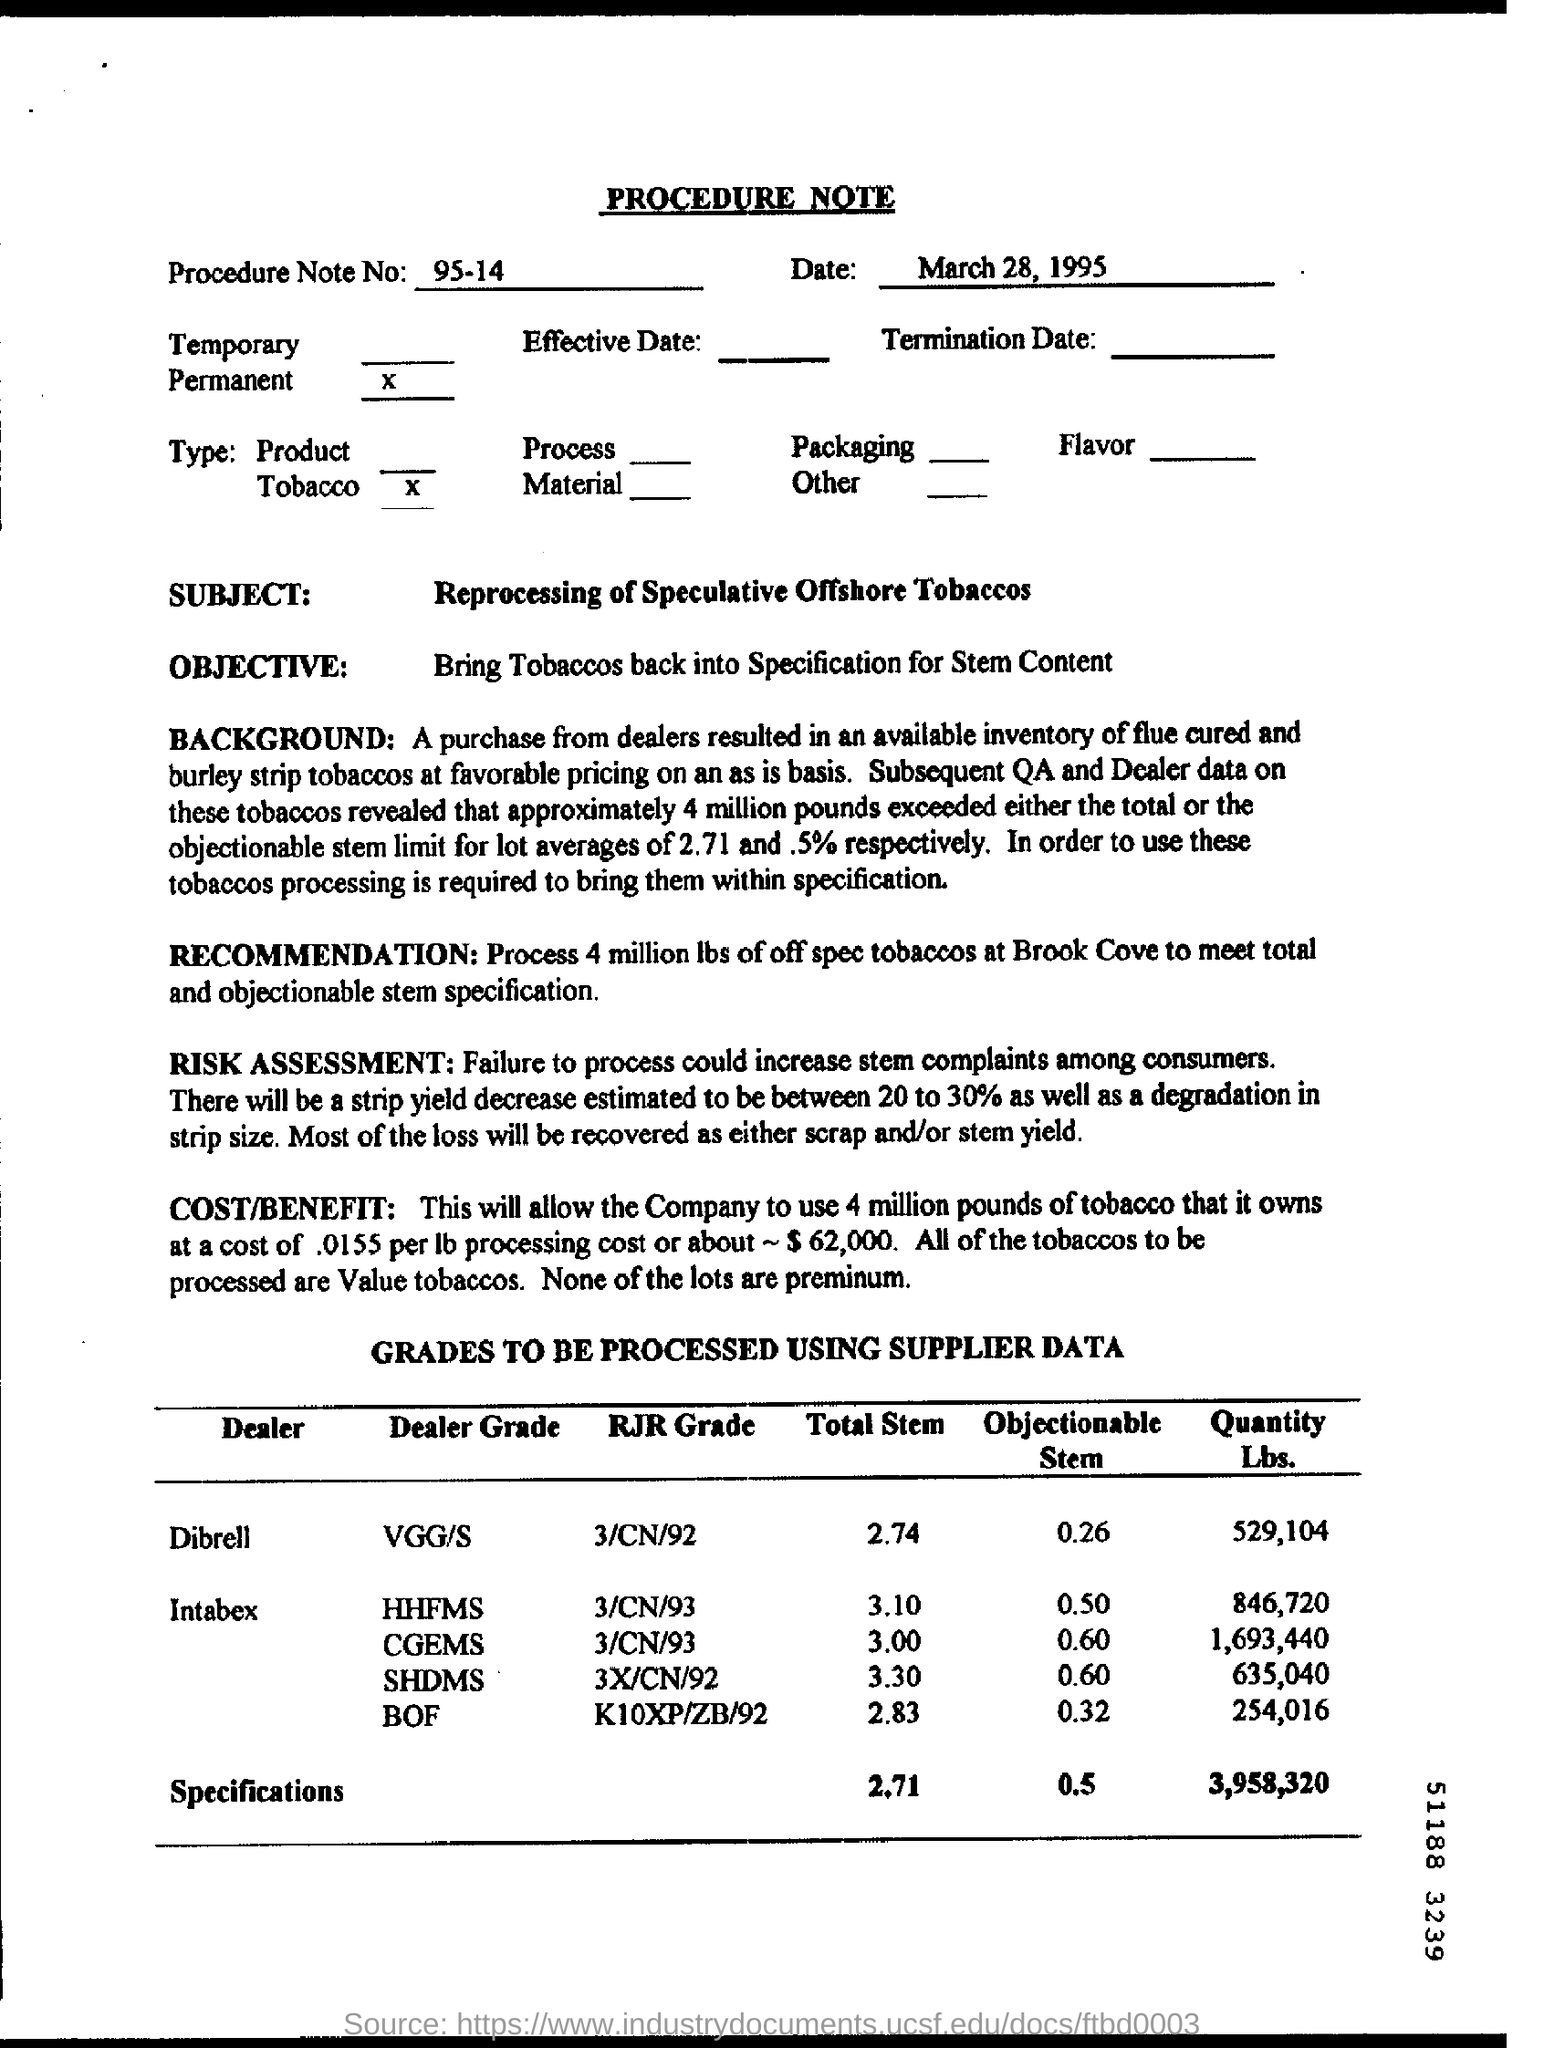Can you describe the key objective outlined in this procedure note? The key objective of Procedure Note No. 95-14 is to bring tobaccos back into specification for stem content, especially after the acquisition of off-spec tobaccos presenting a stem limit over the acceptable average. 